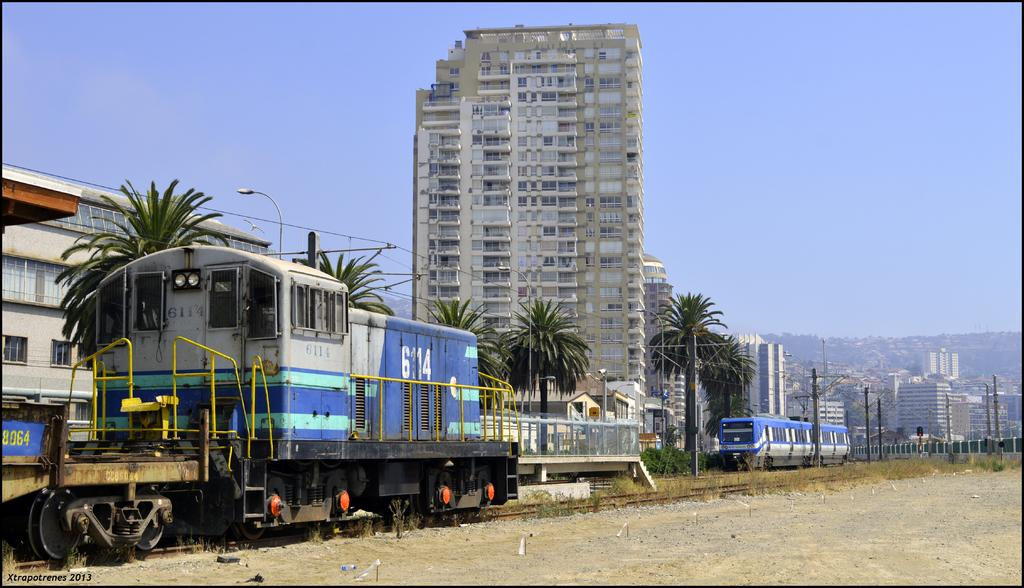What is the main subject of the image? The main subject of the image is trains on the tracks. What can be seen beside the tracks? There are trees and buildings beside the tracks. What other structures are present beside the tracks? There are poles present beside the tracks. What can be seen in the background of the image? There are other buildings in the background of the image. What type of pan is being used to make noise in the image? There is no pan or noise present in the image; it features trains on tracks with surrounding structures. 